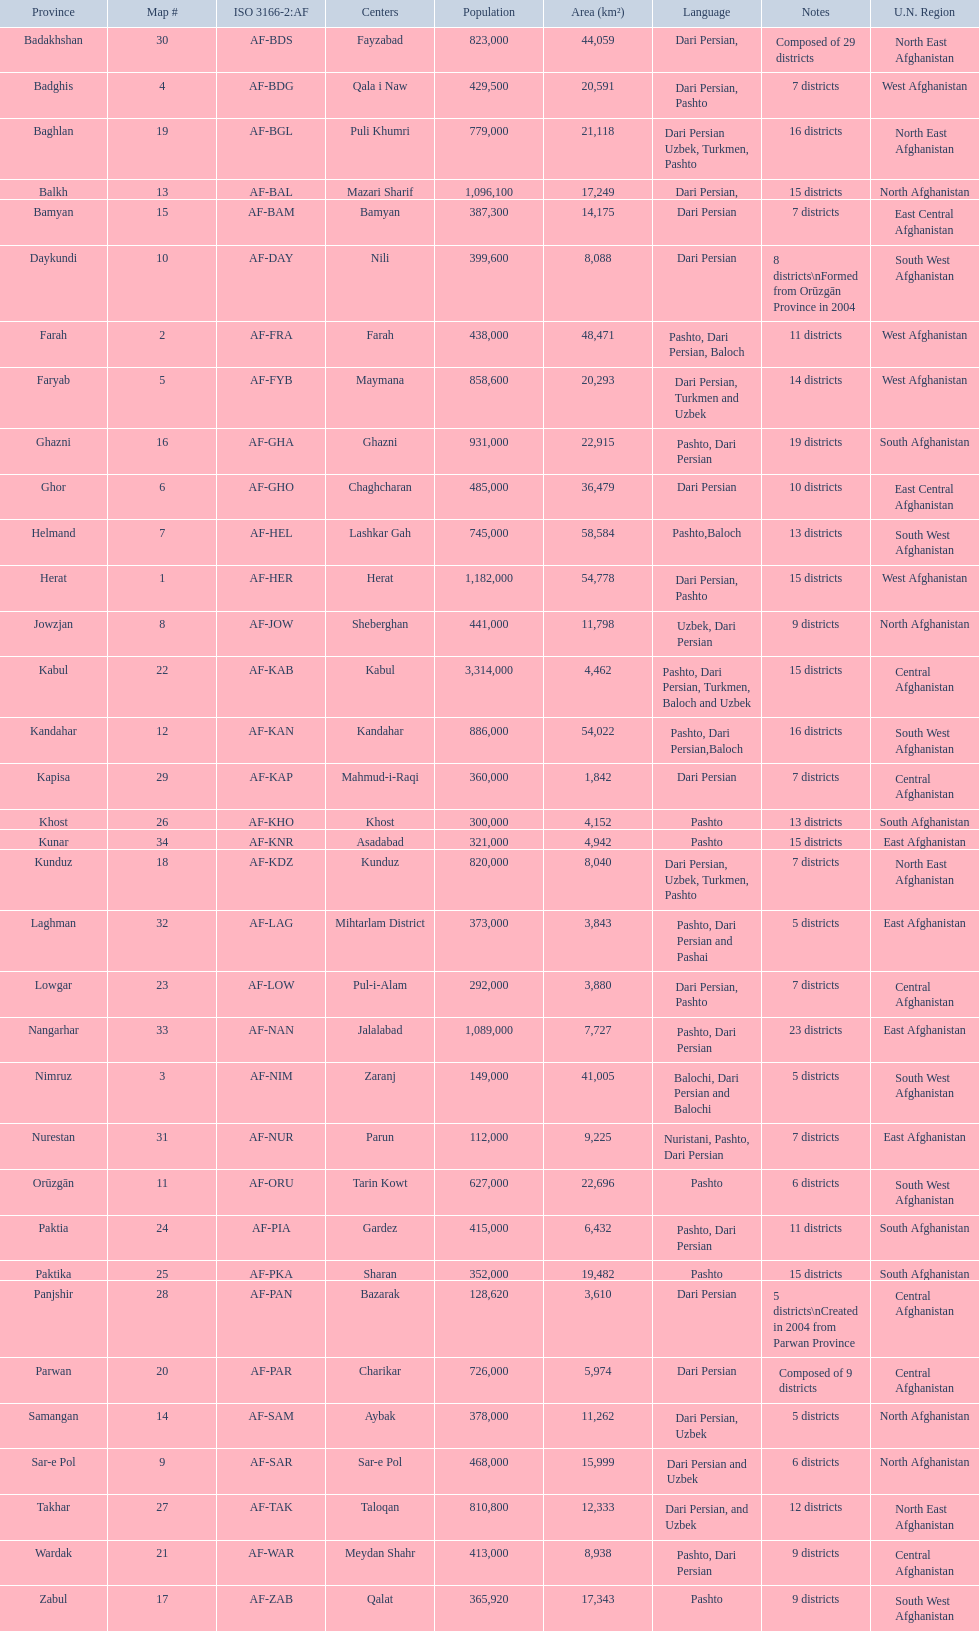With a population of 1,182,000 in herat, can you mention their languages? Dari Persian, Pashto. 